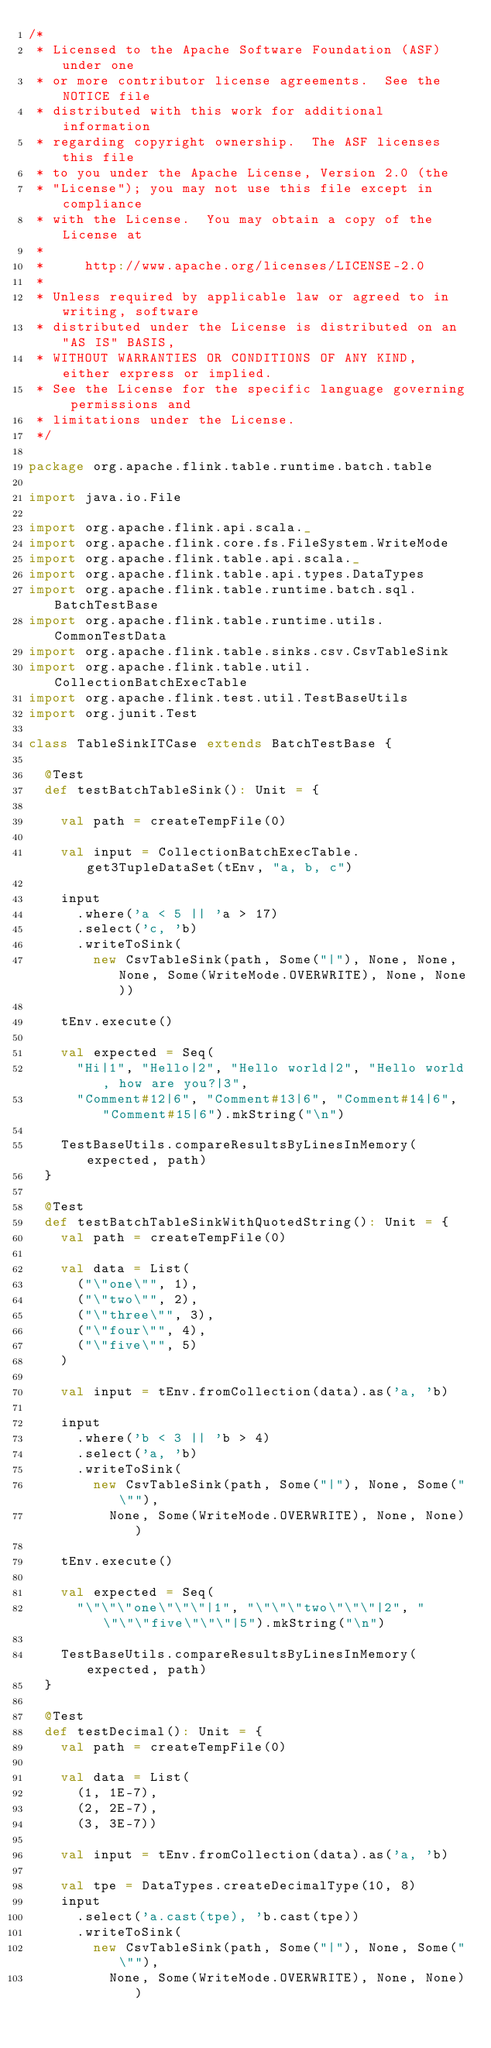Convert code to text. <code><loc_0><loc_0><loc_500><loc_500><_Scala_>/*
 * Licensed to the Apache Software Foundation (ASF) under one
 * or more contributor license agreements.  See the NOTICE file
 * distributed with this work for additional information
 * regarding copyright ownership.  The ASF licenses this file
 * to you under the Apache License, Version 2.0 (the
 * "License"); you may not use this file except in compliance
 * with the License.  You may obtain a copy of the License at
 *
 *     http://www.apache.org/licenses/LICENSE-2.0
 *
 * Unless required by applicable law or agreed to in writing, software
 * distributed under the License is distributed on an "AS IS" BASIS,
 * WITHOUT WARRANTIES OR CONDITIONS OF ANY KIND, either express or implied.
 * See the License for the specific language governing permissions and
 * limitations under the License.
 */

package org.apache.flink.table.runtime.batch.table

import java.io.File

import org.apache.flink.api.scala._
import org.apache.flink.core.fs.FileSystem.WriteMode
import org.apache.flink.table.api.scala._
import org.apache.flink.table.api.types.DataTypes
import org.apache.flink.table.runtime.batch.sql.BatchTestBase
import org.apache.flink.table.runtime.utils.CommonTestData
import org.apache.flink.table.sinks.csv.CsvTableSink
import org.apache.flink.table.util.CollectionBatchExecTable
import org.apache.flink.test.util.TestBaseUtils
import org.junit.Test

class TableSinkITCase extends BatchTestBase {

  @Test
  def testBatchTableSink(): Unit = {

    val path = createTempFile(0)

    val input = CollectionBatchExecTable.get3TupleDataSet(tEnv, "a, b, c")

    input
      .where('a < 5 || 'a > 17)
      .select('c, 'b)
      .writeToSink(
        new CsvTableSink(path, Some("|"), None, None, None, Some(WriteMode.OVERWRITE), None, None))

    tEnv.execute()

    val expected = Seq(
      "Hi|1", "Hello|2", "Hello world|2", "Hello world, how are you?|3",
      "Comment#12|6", "Comment#13|6", "Comment#14|6", "Comment#15|6").mkString("\n")

    TestBaseUtils.compareResultsByLinesInMemory(expected, path)
  }

  @Test
  def testBatchTableSinkWithQuotedString(): Unit = {
    val path = createTempFile(0)

    val data = List(
      ("\"one\"", 1),
      ("\"two\"", 2),
      ("\"three\"", 3),
      ("\"four\"", 4),
      ("\"five\"", 5)
    )

    val input = tEnv.fromCollection(data).as('a, 'b)

    input
      .where('b < 3 || 'b > 4)
      .select('a, 'b)
      .writeToSink(
        new CsvTableSink(path, Some("|"), None, Some("\""),
          None, Some(WriteMode.OVERWRITE), None, None))

    tEnv.execute()

    val expected = Seq(
      "\"\"\"one\"\"\"|1", "\"\"\"two\"\"\"|2", "\"\"\"five\"\"\"|5").mkString("\n")

    TestBaseUtils.compareResultsByLinesInMemory(expected, path)
  }

  @Test
  def testDecimal(): Unit = {
    val path = createTempFile(0)

    val data = List(
      (1, 1E-7),
      (2, 2E-7),
      (3, 3E-7))

    val input = tEnv.fromCollection(data).as('a, 'b)

    val tpe = DataTypes.createDecimalType(10, 8)
    input
      .select('a.cast(tpe), 'b.cast(tpe))
      .writeToSink(
        new CsvTableSink(path, Some("|"), None, Some("\""),
          None, Some(WriteMode.OVERWRITE), None, None))
</code> 